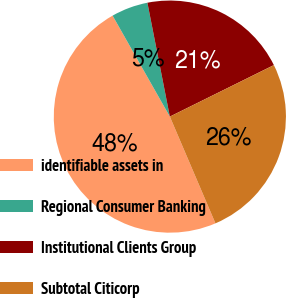Convert chart to OTSL. <chart><loc_0><loc_0><loc_500><loc_500><pie_chart><fcel>identifiable assets in<fcel>Regional Consumer Banking<fcel>Institutional Clients Group<fcel>Subtotal Citicorp<nl><fcel>48.21%<fcel>5.11%<fcel>20.78%<fcel>25.89%<nl></chart> 